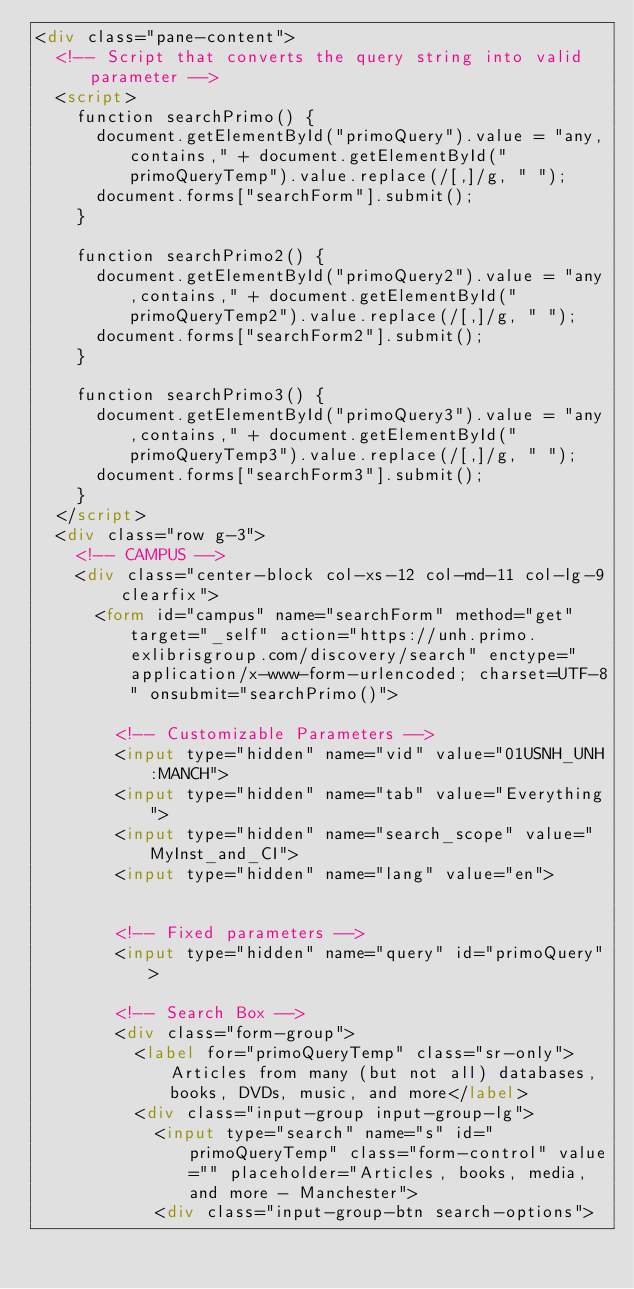Convert code to text. <code><loc_0><loc_0><loc_500><loc_500><_HTML_><div class="pane-content">
  <!-- Script that converts the query string into valid parameter -->
  <script>
    function searchPrimo() {
      document.getElementById("primoQuery").value = "any,contains," + document.getElementById("primoQueryTemp").value.replace(/[,]/g, " ");
      document.forms["searchForm"].submit();
    }

    function searchPrimo2() {
      document.getElementById("primoQuery2").value = "any,contains," + document.getElementById("primoQueryTemp2").value.replace(/[,]/g, " ");
      document.forms["searchForm2"].submit();
    }

    function searchPrimo3() {
      document.getElementById("primoQuery3").value = "any,contains," + document.getElementById("primoQueryTemp3").value.replace(/[,]/g, " ");
      document.forms["searchForm3"].submit();
    }
  </script>
  <div class="row g-3">
    <!-- CAMPUS -->
    <div class="center-block col-xs-12 col-md-11 col-lg-9 clearfix">
      <form id="campus" name="searchForm" method="get" target="_self" action="https://unh.primo.exlibrisgroup.com/discovery/search" enctype="application/x-www-form-urlencoded; charset=UTF-8" onsubmit="searchPrimo()">

        <!-- Customizable Parameters -->
        <input type="hidden" name="vid" value="01USNH_UNH:MANCH">
        <input type="hidden" name="tab" value="Everything">
        <input type="hidden" name="search_scope" value="MyInst_and_CI">
        <input type="hidden" name="lang" value="en">


        <!-- Fixed parameters -->
        <input type="hidden" name="query" id="primoQuery">

        <!-- Search Box -->
        <div class="form-group">
          <label for="primoQueryTemp" class="sr-only">Articles from many (but not all) databases, books, DVDs, music, and more</label>
          <div class="input-group input-group-lg">
            <input type="search" name="s" id="primoQueryTemp" class="form-control" value="" placeholder="Articles, books, media, and more - Manchester">
            <div class="input-group-btn search-options"></code> 